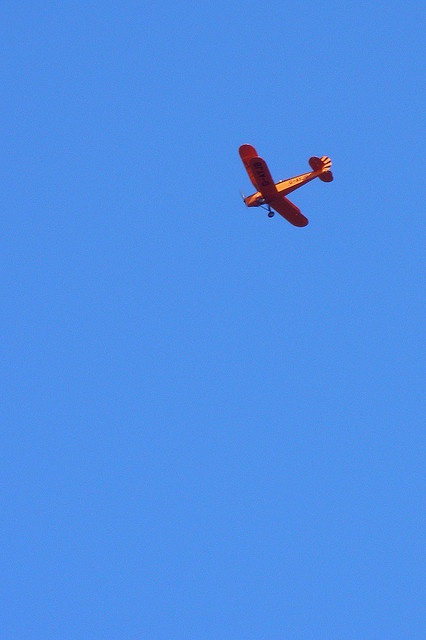Describe the objects in this image and their specific colors. I can see a airplane in gray, maroon, brown, black, and orange tones in this image. 